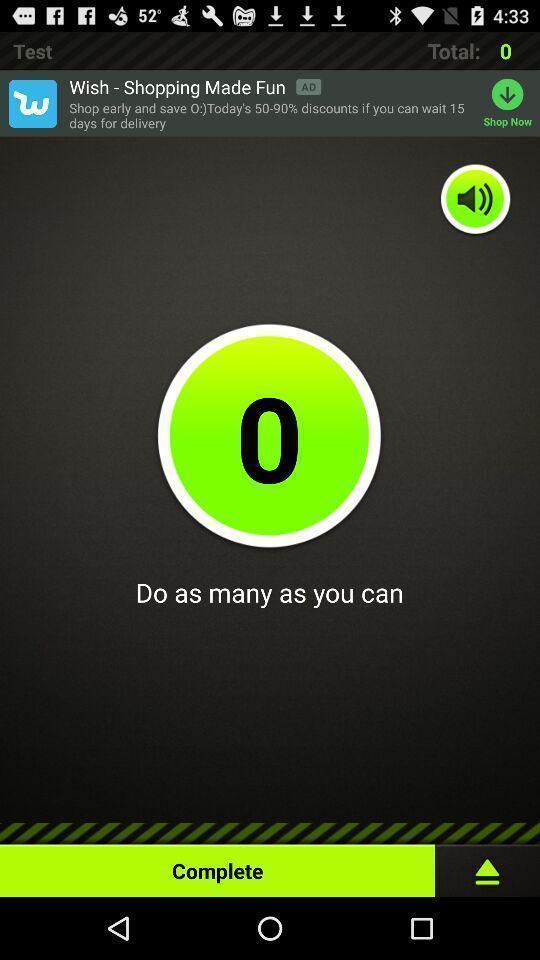Please provide a description for this image. Page showing an interface for a workout related app. 